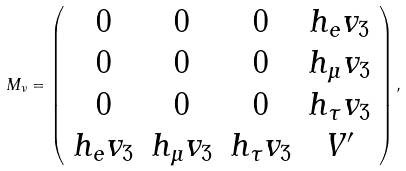<formula> <loc_0><loc_0><loc_500><loc_500>M _ { \nu } = \left ( \begin{array} { c c c c } 0 & 0 & 0 & h _ { e } v _ { 3 } \\ 0 & 0 & 0 & h _ { \mu } v _ { 3 } \\ 0 & 0 & 0 & h _ { \tau } v _ { 3 } \\ h _ { e } v _ { 3 } & h _ { \mu } v _ { 3 } & h _ { \tau } v _ { 3 } & V ^ { \prime } \\ \end{array} \right ) ,</formula> 